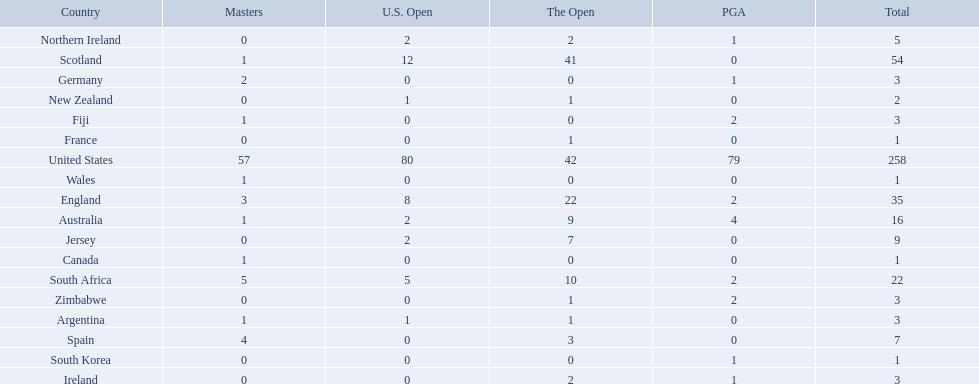What countries in the championship were from africa? South Africa, Zimbabwe. Which of these counteries had the least championship golfers Zimbabwe. 